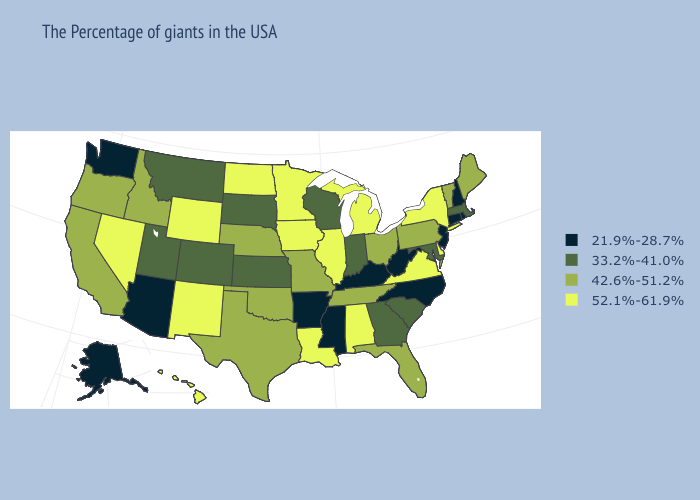Name the states that have a value in the range 33.2%-41.0%?
Concise answer only. Massachusetts, Maryland, South Carolina, Georgia, Indiana, Wisconsin, Kansas, South Dakota, Colorado, Utah, Montana. Does Louisiana have a higher value than Iowa?
Concise answer only. No. Name the states that have a value in the range 52.1%-61.9%?
Concise answer only. New York, Delaware, Virginia, Michigan, Alabama, Illinois, Louisiana, Minnesota, Iowa, North Dakota, Wyoming, New Mexico, Nevada, Hawaii. What is the value of Texas?
Short answer required. 42.6%-51.2%. Name the states that have a value in the range 42.6%-51.2%?
Write a very short answer. Maine, Vermont, Pennsylvania, Ohio, Florida, Tennessee, Missouri, Nebraska, Oklahoma, Texas, Idaho, California, Oregon. Name the states that have a value in the range 33.2%-41.0%?
Concise answer only. Massachusetts, Maryland, South Carolina, Georgia, Indiana, Wisconsin, Kansas, South Dakota, Colorado, Utah, Montana. Does the first symbol in the legend represent the smallest category?
Short answer required. Yes. Name the states that have a value in the range 21.9%-28.7%?
Keep it brief. Rhode Island, New Hampshire, Connecticut, New Jersey, North Carolina, West Virginia, Kentucky, Mississippi, Arkansas, Arizona, Washington, Alaska. What is the lowest value in the MidWest?
Write a very short answer. 33.2%-41.0%. Name the states that have a value in the range 21.9%-28.7%?
Be succinct. Rhode Island, New Hampshire, Connecticut, New Jersey, North Carolina, West Virginia, Kentucky, Mississippi, Arkansas, Arizona, Washington, Alaska. Does Louisiana have a higher value than Minnesota?
Short answer required. No. Name the states that have a value in the range 21.9%-28.7%?
Give a very brief answer. Rhode Island, New Hampshire, Connecticut, New Jersey, North Carolina, West Virginia, Kentucky, Mississippi, Arkansas, Arizona, Washington, Alaska. What is the value of Delaware?
Quick response, please. 52.1%-61.9%. 